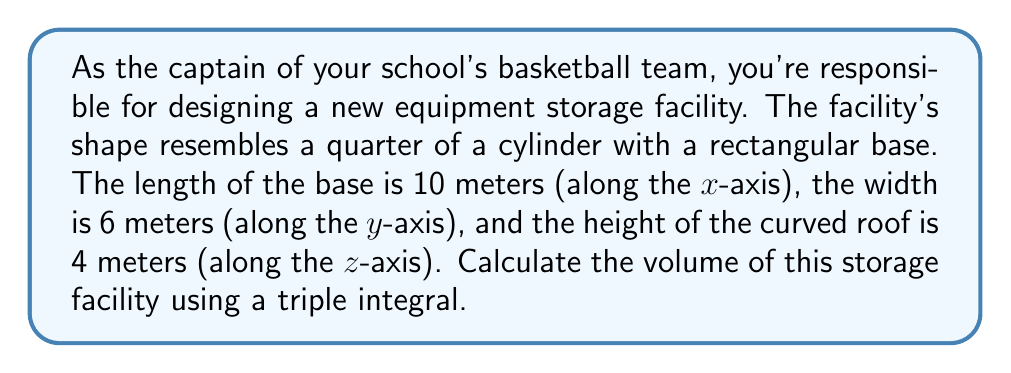Show me your answer to this math problem. Let's approach this step-by-step:

1) The shape is a quarter of a cylinder, so we'll use cylindrical coordinates for our triple integral.

2) The volume in cylindrical coordinates is given by:

   $$V = \int_0^R \int_0^{\frac{\pi}{2}} \int_0^L r \, dz \, d\theta \, dr$$

   Where $R$ is the radius (width of the base), $\frac{\pi}{2}$ represents a quarter of a full circle, and $L$ is the length of the base.

3) From the given dimensions:
   $R = 6$ meters (width of the base)
   $L = 10$ meters (length of the base)

4) Set up the triple integral:

   $$V = \int_0^6 \int_0^{\frac{\pi}{2}} \int_0^{10} r \, dz \, d\theta \, dr$$

5) Solve the innermost integral (with respect to $z$):

   $$V = \int_0^6 \int_0^{\frac{\pi}{2}} [10r] \, d\theta \, dr$$

6) Solve the middle integral (with respect to $\theta$):

   $$V = \int_0^6 [10r \cdot \frac{\pi}{2}] \, dr = 5\pi \int_0^6 r \, dr$$

7) Solve the outermost integral (with respect to $r$):

   $$V = 5\pi [\frac{r^2}{2}]_0^6 = 5\pi (\frac{36}{2} - 0) = 90\pi$$

Therefore, the volume of the storage facility is $90\pi$ cubic meters.
Answer: $90\pi$ cubic meters 